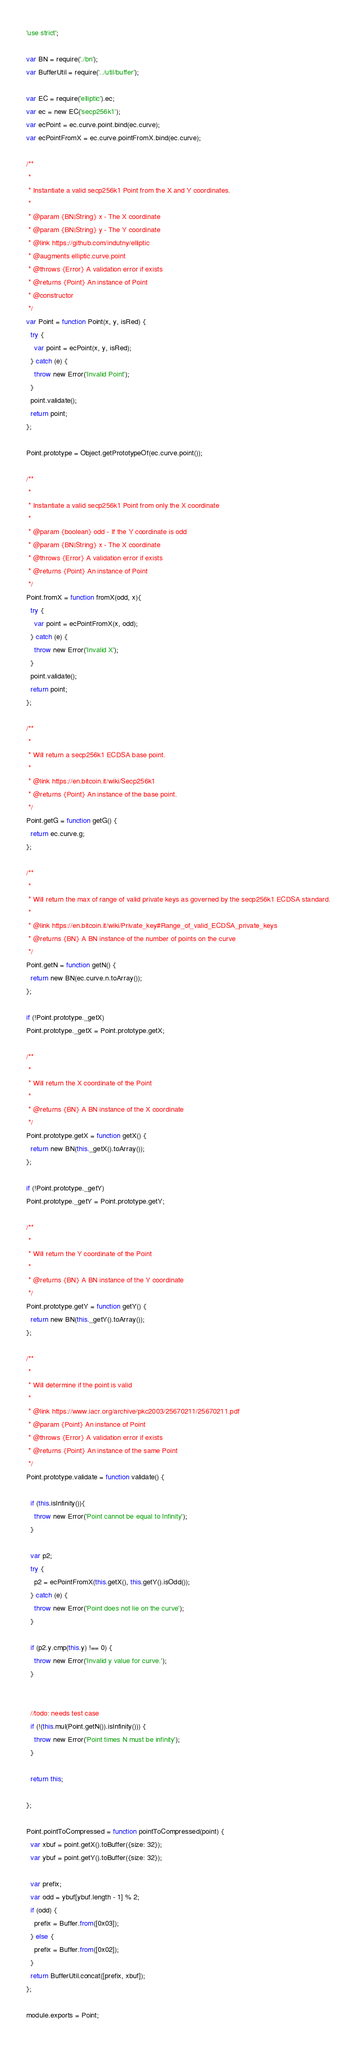<code> <loc_0><loc_0><loc_500><loc_500><_JavaScript_>'use strict';

var BN = require('./bn');
var BufferUtil = require('../util/buffer');

var EC = require('elliptic').ec;
var ec = new EC('secp256k1');
var ecPoint = ec.curve.point.bind(ec.curve);
var ecPointFromX = ec.curve.pointFromX.bind(ec.curve);

/**
 *
 * Instantiate a valid secp256k1 Point from the X and Y coordinates.
 *
 * @param {BN|String} x - The X coordinate
 * @param {BN|String} y - The Y coordinate
 * @link https://github.com/indutny/elliptic
 * @augments elliptic.curve.point
 * @throws {Error} A validation error if exists
 * @returns {Point} An instance of Point
 * @constructor
 */
var Point = function Point(x, y, isRed) {
  try {
    var point = ecPoint(x, y, isRed);
  } catch (e) {
    throw new Error('Invalid Point');
  }
  point.validate();
  return point;
};

Point.prototype = Object.getPrototypeOf(ec.curve.point());

/**
 *
 * Instantiate a valid secp256k1 Point from only the X coordinate
 *
 * @param {boolean} odd - If the Y coordinate is odd
 * @param {BN|String} x - The X coordinate
 * @throws {Error} A validation error if exists
 * @returns {Point} An instance of Point
 */
Point.fromX = function fromX(odd, x){
  try {
    var point = ecPointFromX(x, odd);
  } catch (e) {
    throw new Error('Invalid X');
  }
  point.validate();
  return point;
};

/**
 *
 * Will return a secp256k1 ECDSA base point.
 *
 * @link https://en.bitcoin.it/wiki/Secp256k1
 * @returns {Point} An instance of the base point.
 */
Point.getG = function getG() {
  return ec.curve.g;
};

/**
 *
 * Will return the max of range of valid private keys as governed by the secp256k1 ECDSA standard.
 *
 * @link https://en.bitcoin.it/wiki/Private_key#Range_of_valid_ECDSA_private_keys
 * @returns {BN} A BN instance of the number of points on the curve
 */
Point.getN = function getN() {
  return new BN(ec.curve.n.toArray());
};

if (!Point.prototype._getX)
Point.prototype._getX = Point.prototype.getX;

/**
 *
 * Will return the X coordinate of the Point
 *
 * @returns {BN} A BN instance of the X coordinate
 */
Point.prototype.getX = function getX() {
  return new BN(this._getX().toArray());
};

if (!Point.prototype._getY)
Point.prototype._getY = Point.prototype.getY;

/**
 *
 * Will return the Y coordinate of the Point
 *
 * @returns {BN} A BN instance of the Y coordinate
 */
Point.prototype.getY = function getY() {
  return new BN(this._getY().toArray());
};

/**
 *
 * Will determine if the point is valid
 *
 * @link https://www.iacr.org/archive/pkc2003/25670211/25670211.pdf
 * @param {Point} An instance of Point
 * @throws {Error} A validation error if exists
 * @returns {Point} An instance of the same Point
 */
Point.prototype.validate = function validate() {

  if (this.isInfinity()){
    throw new Error('Point cannot be equal to Infinity');
  }

  var p2;
  try {
    p2 = ecPointFromX(this.getX(), this.getY().isOdd());
  } catch (e) {
    throw new Error('Point does not lie on the curve');
  }

  if (p2.y.cmp(this.y) !== 0) {
    throw new Error('Invalid y value for curve.');
  }


  //todo: needs test case
  if (!(this.mul(Point.getN()).isInfinity())) {
    throw new Error('Point times N must be infinity');
  }

  return this;

};

Point.pointToCompressed = function pointToCompressed(point) {
  var xbuf = point.getX().toBuffer({size: 32});
  var ybuf = point.getY().toBuffer({size: 32});

  var prefix;
  var odd = ybuf[ybuf.length - 1] % 2;
  if (odd) {
    prefix = Buffer.from([0x03]);
  } else {
    prefix = Buffer.from([0x02]);
  }
  return BufferUtil.concat([prefix, xbuf]);
};

module.exports = Point;
</code> 